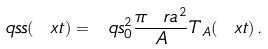<formula> <loc_0><loc_0><loc_500><loc_500>\ q s s ( \ x t ) = \ q s _ { 0 } ^ { 2 } \frac { \pi \ r a ^ { 2 } } { A } T _ { A } ( \ x t ) \, .</formula> 